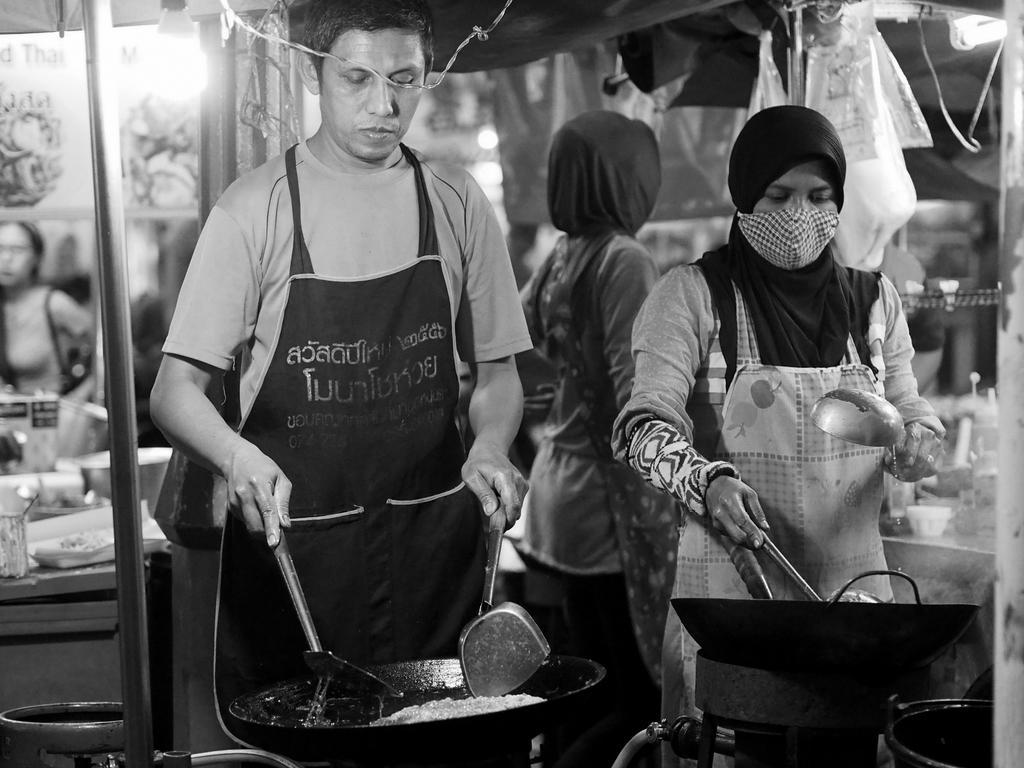Can you describe this image briefly? This is a black and white picture. In this picture, we see a man wearing a black apron is cooking. Beside him, we see a woman is also cooking. Behind them, the woman is standing. On the left side, we see a woman is sitting. In the background, we see lights, trees and plastic covers. This picture might be clicked in the stalls. 